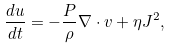<formula> <loc_0><loc_0><loc_500><loc_500>\frac { d u } { d t } = - \frac { P } { \rho } \nabla \cdot { v } + \eta J ^ { 2 } ,</formula> 